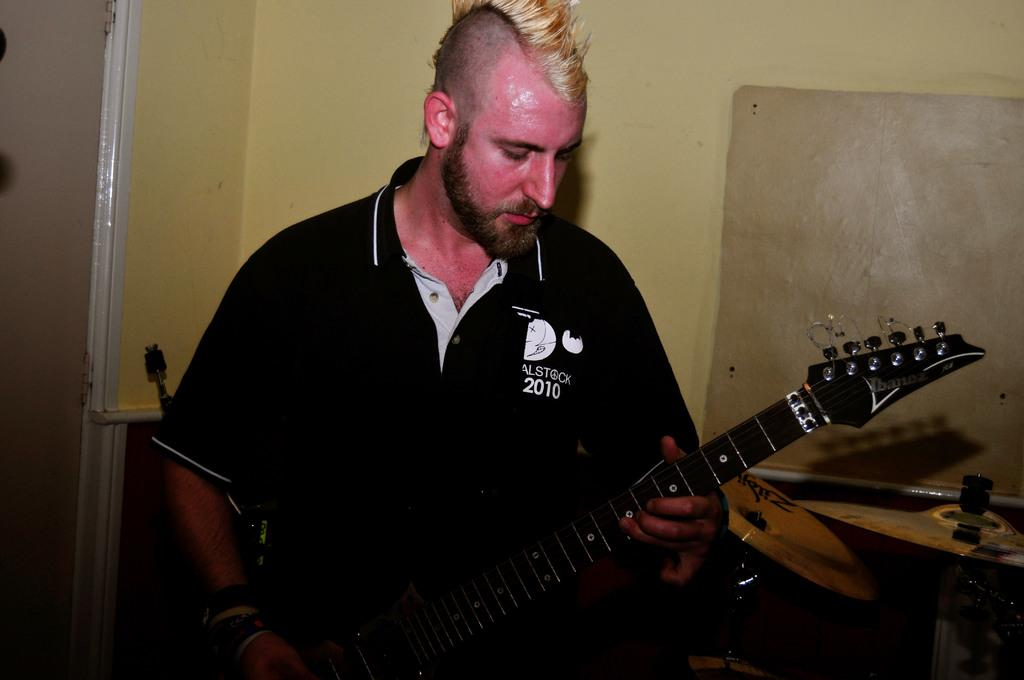What is the man in the image holding? The man is holding a guitar in the image. What is the man wearing in the image? The man is wearing a black T-shirt in the image. How would you describe the man's hairstyle in the image? The man has a funky hairstyle in the image. What can be seen in the background of the image? There is a yellow wall with a door in the background of the image. Is there a boat visible in the image? No, there is no boat present in the image. What type of copper material can be seen in the image? There is no copper material visible in the image. 